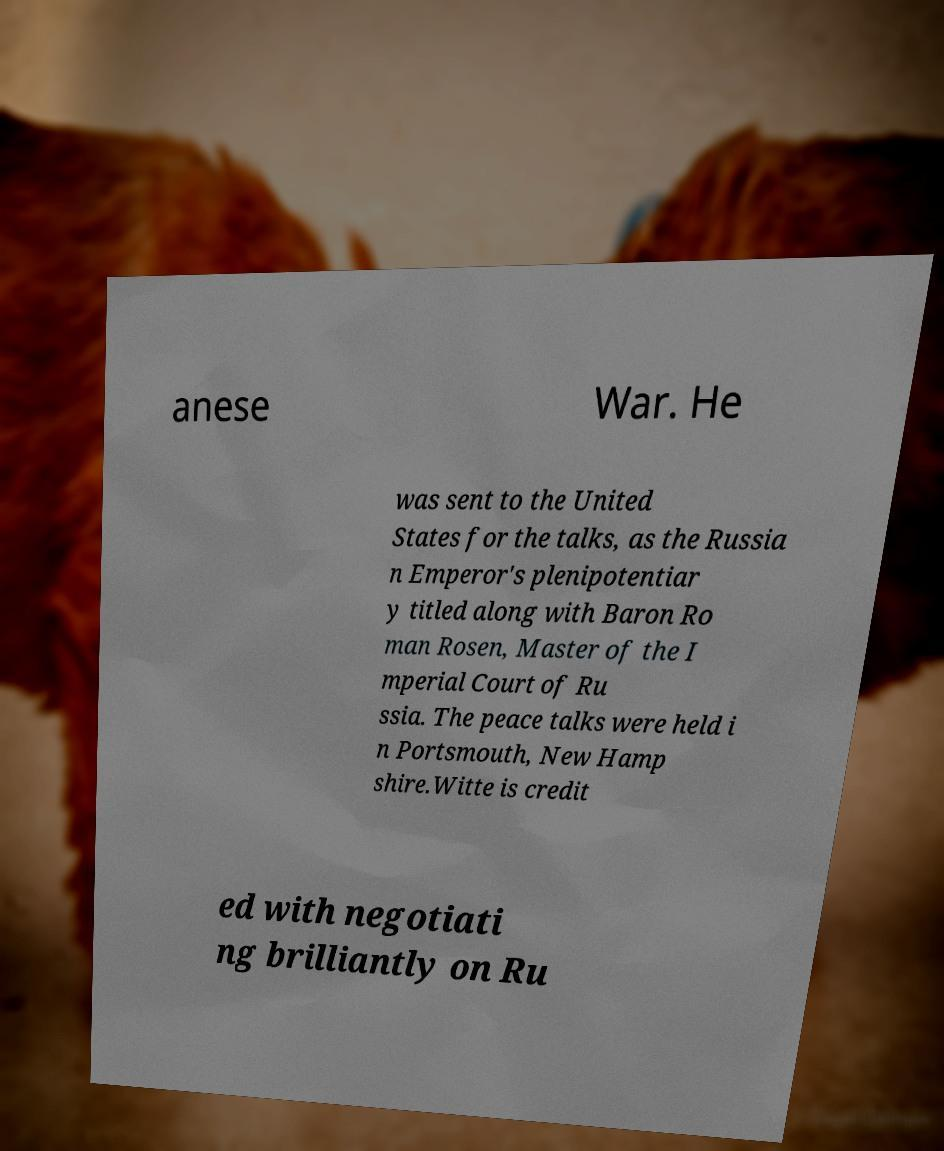Please read and relay the text visible in this image. What does it say? anese War. He was sent to the United States for the talks, as the Russia n Emperor's plenipotentiar y titled along with Baron Ro man Rosen, Master of the I mperial Court of Ru ssia. The peace talks were held i n Portsmouth, New Hamp shire.Witte is credit ed with negotiati ng brilliantly on Ru 